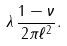Convert formula to latex. <formula><loc_0><loc_0><loc_500><loc_500>\lambda \, \frac { 1 - \nu } { 2 \pi \ell ^ { 2 } } .</formula> 